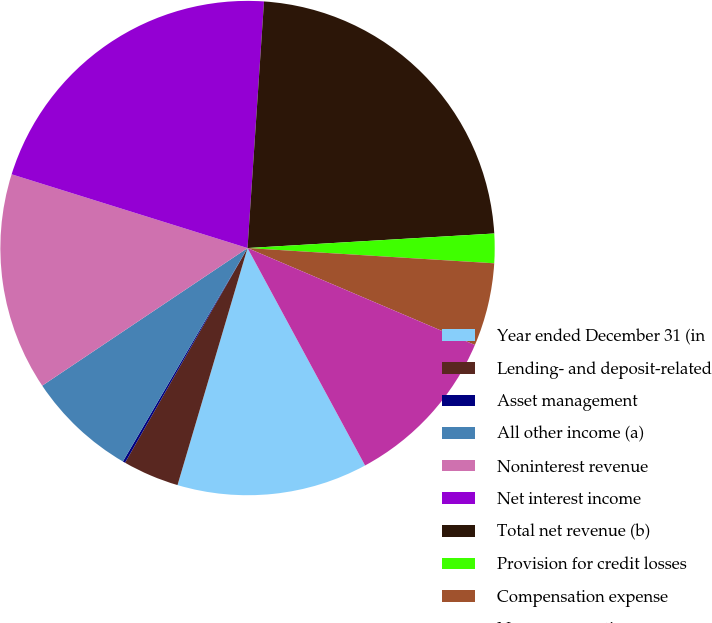Convert chart. <chart><loc_0><loc_0><loc_500><loc_500><pie_chart><fcel>Year ended December 31 (in<fcel>Lending- and deposit-related<fcel>Asset management<fcel>All other income (a)<fcel>Noninterest revenue<fcel>Net interest income<fcel>Total net revenue (b)<fcel>Provision for credit losses<fcel>Compensation expense<fcel>Noncompensation expense<nl><fcel>12.46%<fcel>3.68%<fcel>0.16%<fcel>7.19%<fcel>14.22%<fcel>21.24%<fcel>23.0%<fcel>1.92%<fcel>5.43%<fcel>10.7%<nl></chart> 